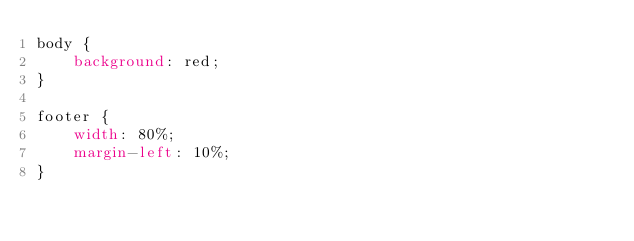Convert code to text. <code><loc_0><loc_0><loc_500><loc_500><_CSS_>body {
    background: red;
}

footer {
    width: 80%;
    margin-left: 10%;
}</code> 